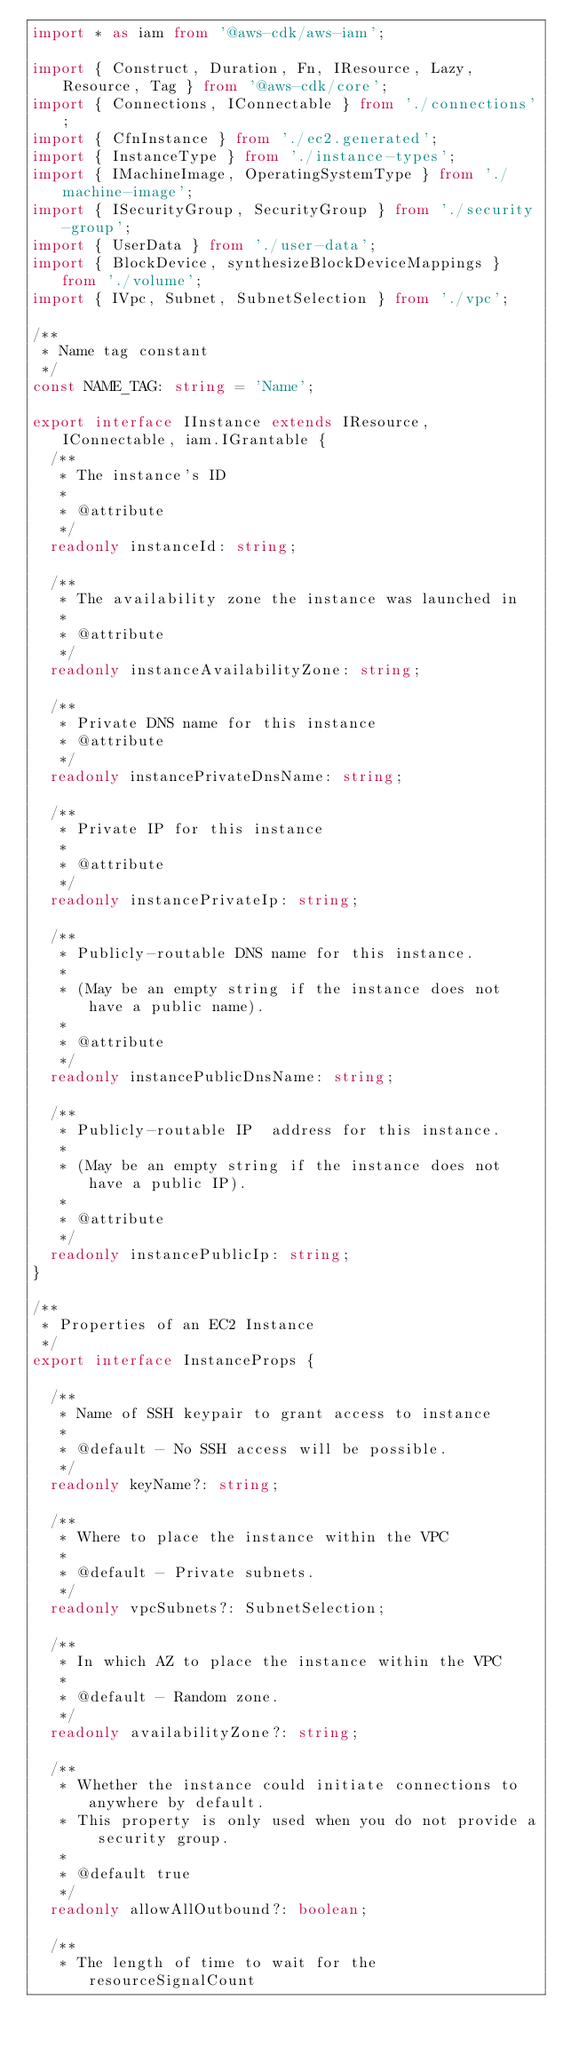Convert code to text. <code><loc_0><loc_0><loc_500><loc_500><_TypeScript_>import * as iam from '@aws-cdk/aws-iam';

import { Construct, Duration, Fn, IResource, Lazy, Resource, Tag } from '@aws-cdk/core';
import { Connections, IConnectable } from './connections';
import { CfnInstance } from './ec2.generated';
import { InstanceType } from './instance-types';
import { IMachineImage, OperatingSystemType } from './machine-image';
import { ISecurityGroup, SecurityGroup } from './security-group';
import { UserData } from './user-data';
import { BlockDevice, synthesizeBlockDeviceMappings } from './volume';
import { IVpc, Subnet, SubnetSelection } from './vpc';

/**
 * Name tag constant
 */
const NAME_TAG: string = 'Name';

export interface IInstance extends IResource, IConnectable, iam.IGrantable {
  /**
   * The instance's ID
   *
   * @attribute
   */
  readonly instanceId: string;

  /**
   * The availability zone the instance was launched in
   *
   * @attribute
   */
  readonly instanceAvailabilityZone: string;

  /**
   * Private DNS name for this instance
   * @attribute
   */
  readonly instancePrivateDnsName: string;

  /**
   * Private IP for this instance
   *
   * @attribute
   */
  readonly instancePrivateIp: string;

  /**
   * Publicly-routable DNS name for this instance.
   *
   * (May be an empty string if the instance does not have a public name).
   *
   * @attribute
   */
  readonly instancePublicDnsName: string;

  /**
   * Publicly-routable IP  address for this instance.
   *
   * (May be an empty string if the instance does not have a public IP).
   *
   * @attribute
   */
  readonly instancePublicIp: string;
}

/**
 * Properties of an EC2 Instance
 */
export interface InstanceProps {

  /**
   * Name of SSH keypair to grant access to instance
   *
   * @default - No SSH access will be possible.
   */
  readonly keyName?: string;

  /**
   * Where to place the instance within the VPC
   *
   * @default - Private subnets.
   */
  readonly vpcSubnets?: SubnetSelection;

  /**
   * In which AZ to place the instance within the VPC
   *
   * @default - Random zone.
   */
  readonly availabilityZone?: string;

  /**
   * Whether the instance could initiate connections to anywhere by default.
   * This property is only used when you do not provide a security group.
   *
   * @default true
   */
  readonly allowAllOutbound?: boolean;

  /**
   * The length of time to wait for the resourceSignalCount</code> 